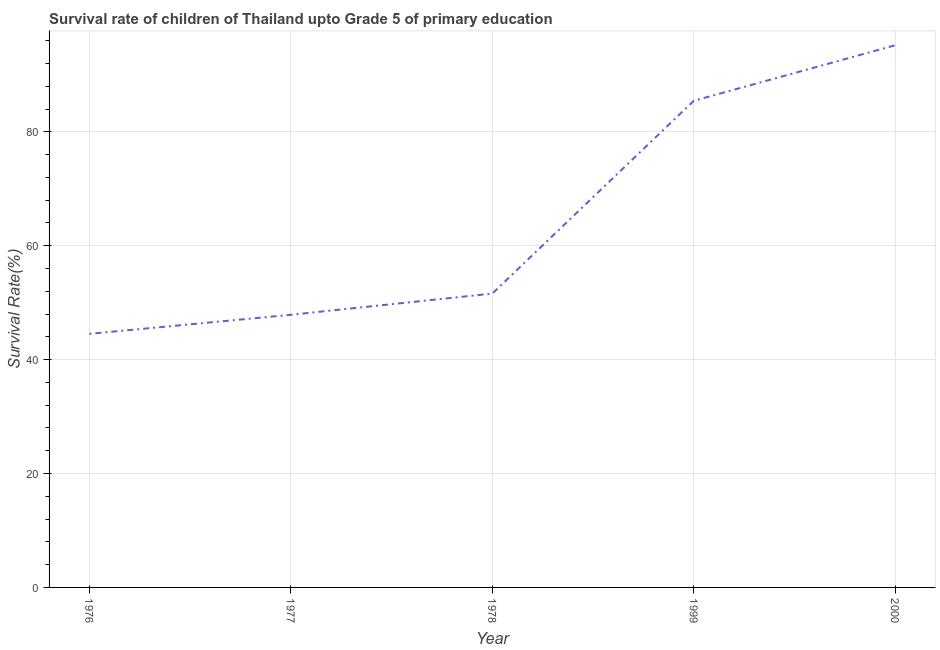What is the survival rate in 1999?
Your answer should be compact. 85.46. Across all years, what is the maximum survival rate?
Ensure brevity in your answer.  95.21. Across all years, what is the minimum survival rate?
Give a very brief answer. 44.53. In which year was the survival rate minimum?
Your response must be concise. 1976. What is the sum of the survival rate?
Ensure brevity in your answer.  324.69. What is the difference between the survival rate in 1977 and 1978?
Provide a short and direct response. -3.72. What is the average survival rate per year?
Give a very brief answer. 64.94. What is the median survival rate?
Provide a short and direct response. 51.6. What is the ratio of the survival rate in 1978 to that in 2000?
Offer a terse response. 0.54. Is the difference between the survival rate in 1978 and 1999 greater than the difference between any two years?
Provide a succinct answer. No. What is the difference between the highest and the second highest survival rate?
Make the answer very short. 9.75. Is the sum of the survival rate in 1976 and 1978 greater than the maximum survival rate across all years?
Keep it short and to the point. Yes. What is the difference between the highest and the lowest survival rate?
Your response must be concise. 50.68. In how many years, is the survival rate greater than the average survival rate taken over all years?
Give a very brief answer. 2. How many years are there in the graph?
Make the answer very short. 5. What is the difference between two consecutive major ticks on the Y-axis?
Make the answer very short. 20. Does the graph contain any zero values?
Give a very brief answer. No. Does the graph contain grids?
Make the answer very short. Yes. What is the title of the graph?
Your answer should be compact. Survival rate of children of Thailand upto Grade 5 of primary education. What is the label or title of the X-axis?
Offer a very short reply. Year. What is the label or title of the Y-axis?
Keep it short and to the point. Survival Rate(%). What is the Survival Rate(%) in 1976?
Your answer should be compact. 44.53. What is the Survival Rate(%) in 1977?
Your answer should be compact. 47.88. What is the Survival Rate(%) in 1978?
Your answer should be compact. 51.6. What is the Survival Rate(%) in 1999?
Offer a terse response. 85.46. What is the Survival Rate(%) in 2000?
Provide a short and direct response. 95.21. What is the difference between the Survival Rate(%) in 1976 and 1977?
Keep it short and to the point. -3.35. What is the difference between the Survival Rate(%) in 1976 and 1978?
Provide a succinct answer. -7.07. What is the difference between the Survival Rate(%) in 1976 and 1999?
Your answer should be compact. -40.93. What is the difference between the Survival Rate(%) in 1976 and 2000?
Offer a very short reply. -50.68. What is the difference between the Survival Rate(%) in 1977 and 1978?
Offer a very short reply. -3.72. What is the difference between the Survival Rate(%) in 1977 and 1999?
Your answer should be compact. -37.58. What is the difference between the Survival Rate(%) in 1977 and 2000?
Give a very brief answer. -47.33. What is the difference between the Survival Rate(%) in 1978 and 1999?
Offer a terse response. -33.86. What is the difference between the Survival Rate(%) in 1978 and 2000?
Offer a very short reply. -43.61. What is the difference between the Survival Rate(%) in 1999 and 2000?
Your answer should be very brief. -9.75. What is the ratio of the Survival Rate(%) in 1976 to that in 1978?
Keep it short and to the point. 0.86. What is the ratio of the Survival Rate(%) in 1976 to that in 1999?
Your response must be concise. 0.52. What is the ratio of the Survival Rate(%) in 1976 to that in 2000?
Your answer should be compact. 0.47. What is the ratio of the Survival Rate(%) in 1977 to that in 1978?
Offer a terse response. 0.93. What is the ratio of the Survival Rate(%) in 1977 to that in 1999?
Offer a very short reply. 0.56. What is the ratio of the Survival Rate(%) in 1977 to that in 2000?
Your response must be concise. 0.5. What is the ratio of the Survival Rate(%) in 1978 to that in 1999?
Ensure brevity in your answer.  0.6. What is the ratio of the Survival Rate(%) in 1978 to that in 2000?
Keep it short and to the point. 0.54. What is the ratio of the Survival Rate(%) in 1999 to that in 2000?
Give a very brief answer. 0.9. 